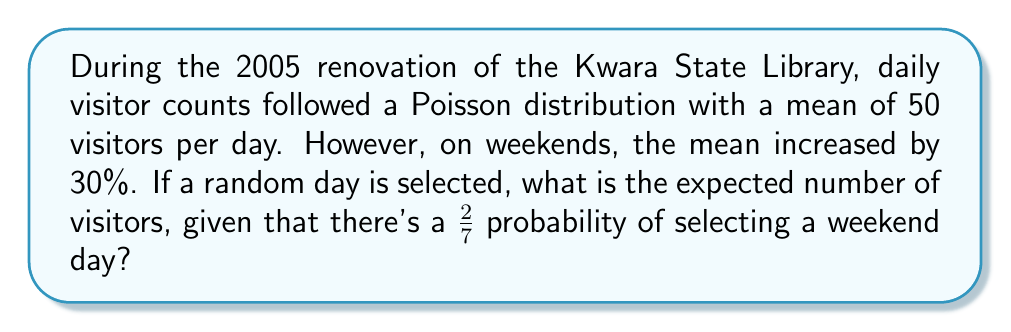Can you solve this math problem? Let's approach this step-by-step:

1) Let $X$ be the number of visitors on a given day.

2) For weekdays (5/7 of the time):
   $X \sim \text{Poisson}(\lambda = 50)$

3) For weekends (2/7 of the time):
   $X \sim \text{Poisson}(\lambda = 50 \times 1.3 = 65)$

4) The expected value of a Poisson distribution is equal to its parameter $\lambda$.

5) We can use the law of total expectation:

   $E[X] = E[X|\text{Weekday}] \cdot P(\text{Weekday}) + E[X|\text{Weekend}] \cdot P(\text{Weekend})$

6) Substituting the values:

   $E[X] = 50 \cdot \frac{5}{7} + 65 \cdot \frac{2}{7}$

7) Calculating:

   $E[X] = \frac{250}{7} + \frac{130}{7} = \frac{380}{7} \approx 54.29$
Answer: $\frac{380}{7}$ visitors (or approximately 54.29 visitors) 